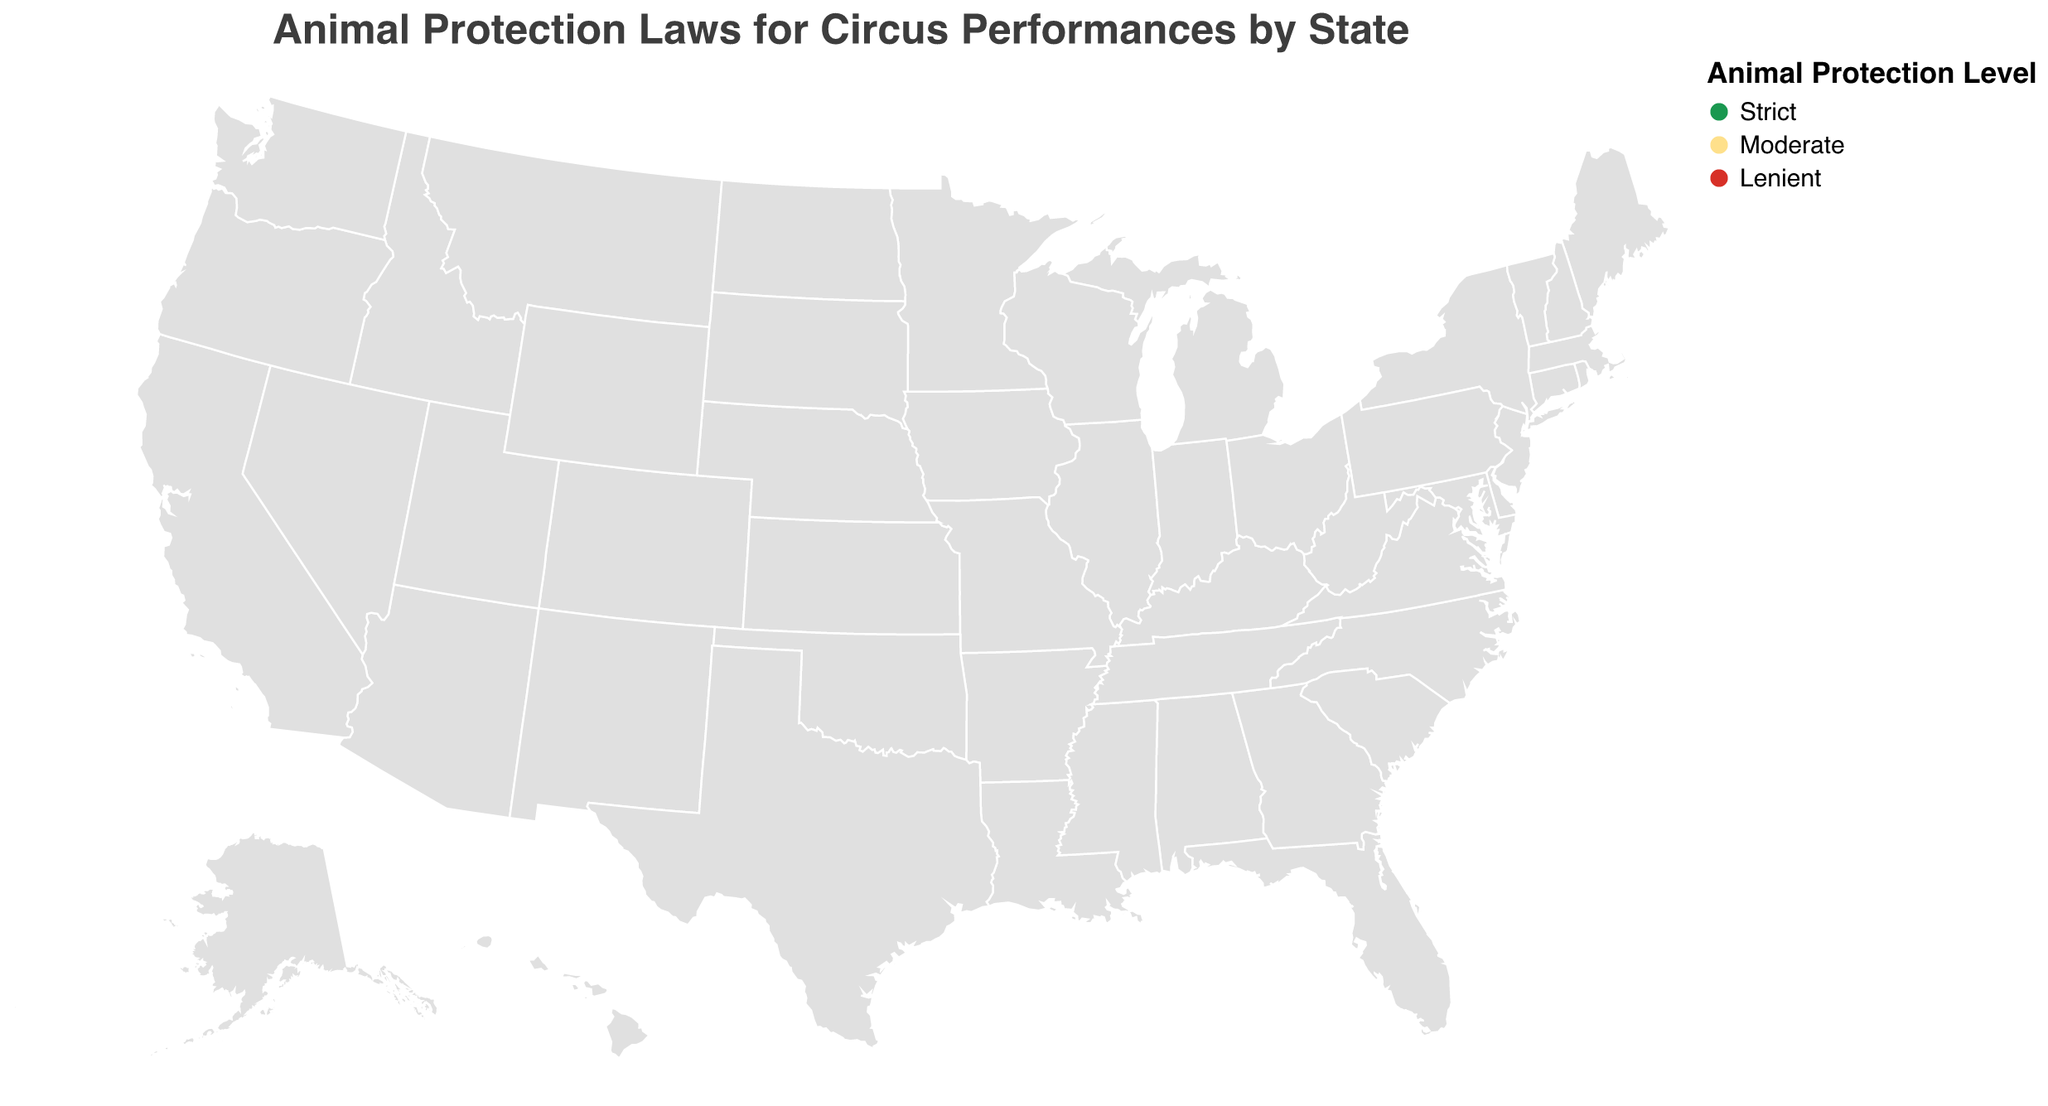Which states have strict animal protection laws for circus performances? Look for states colored in the shade assigned to the "Strict" level in the legend.
Answer: California, New York, Massachusetts, New Jersey, Washington, Oregon How many states have moderate animal protection laws for circus performances? Count the states colored in the shade assigned to the "Moderate" level in the legend.
Answer: 8 Which has more states, those with lenient or moderate animal protection laws? Count the number of states labeled as "Lenient" and "Moderate" and compare. Lenient has 7 states, and Moderate has 8 states.
Answer: Moderate Are there more states with lenient animal protection laws in the eastern or western half of the United States? Identify the states in the eastern and western halves of the U.S. and count the number labeled as "Lenient." In the east: Texas, Ohio, Georgia, Indiana, Tennessee, Missouri. In the west: Wisconsin. The east has 6 states, and the west has 1 state.
Answer: Eastern What percentage of the total states have strict animal protection laws? Count the total number of states and the number labeled as "Strict," then calculate the percentage. Total states: 20, strict states: 6. Calculation: (6/20) * 100 = 30%
Answer: 30% Is there a correlation between geographic location and level of animal protection laws? Check if there is any observable pattern based on the map's color distribution. For example, are strict laws more common in the coastal states? Identify the pattern and explain.
Answer: Coastal states tend to have stricter laws (e.g., California, New York, Massachusetts, New Jersey, Washington, Oregon) Which state has the most lenient animal protection laws for circus performances in the Midwest? Identify states in the Midwest and find those labeled as "Lenient." States include Ohio, Indiana, Wisconsin, and Missouri.
Answer: Missouri Are there any strict animal protection states clustered together geographically? Look for a group of states, colored in the shade representing "Strict," located next to each other. Identify those states.
Answer: Yes, the Northeastern region has New York, Massachusetts, and New Jersey clustered Does any state have more lenient laws for circus performances despite being geographically close to states with stricter laws? Check for states labeled as "Lenient" located next to or near states labeled as "Strict."
Answer: Ohio is lenient and near states like Pennsylvania (Moderate) and New York (Strict) Which state has no specific animal protection level indicated in the diagram? List of states provided for the figure includes all that have indicated levels. Any state from the U.S. not listed would have no level indicated. One example could be Alaska, which is not mentioned.
Answer: Alaska 